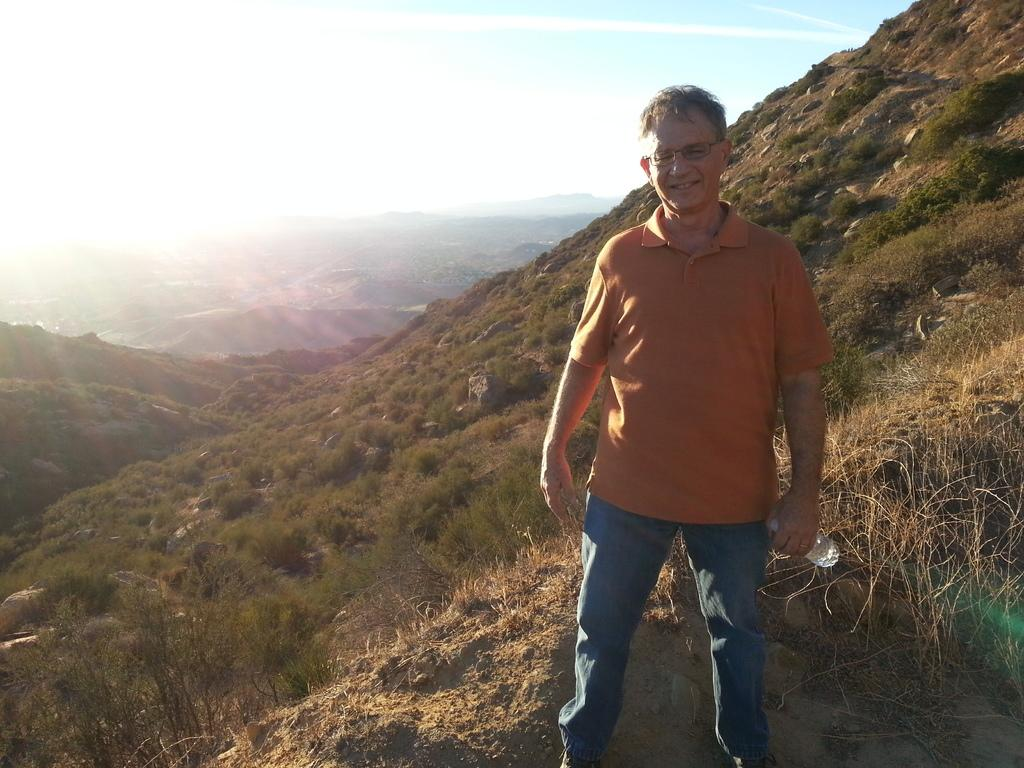What is the person in the image doing? The person is standing and smiling in the image. What is the person holding in the image? The person is holding a bottle in the image. What can be seen in the background of the image? There are trees, hills, and the sky visible in the background of the image. What type of gold can be seen in the image? There is no gold present in the image. Is there a stream visible in the image? There is no stream visible in the image; only trees, hills, and the sky are present in the background. 